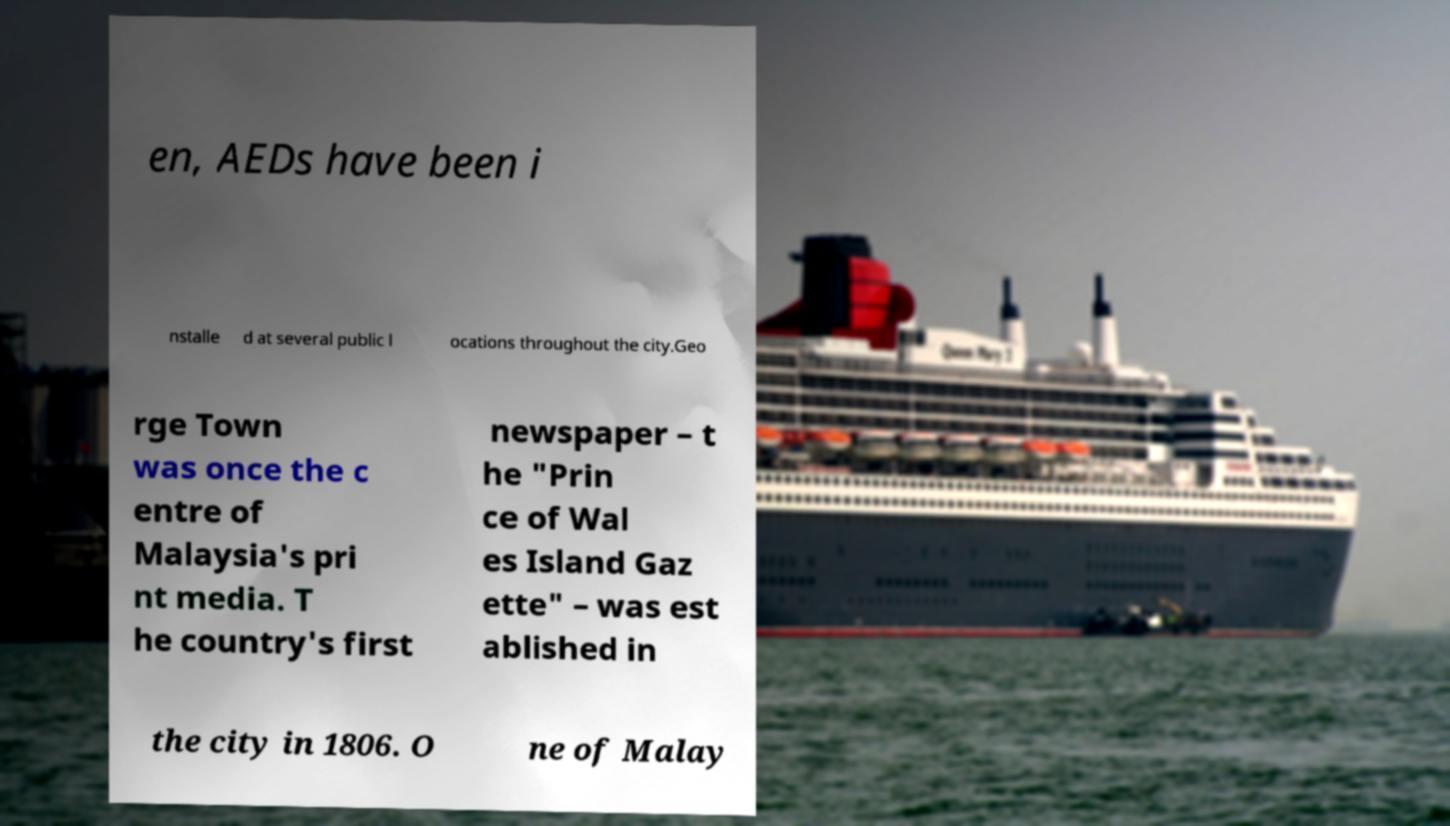Could you extract and type out the text from this image? en, AEDs have been i nstalle d at several public l ocations throughout the city.Geo rge Town was once the c entre of Malaysia's pri nt media. T he country's first newspaper – t he "Prin ce of Wal es Island Gaz ette" – was est ablished in the city in 1806. O ne of Malay 